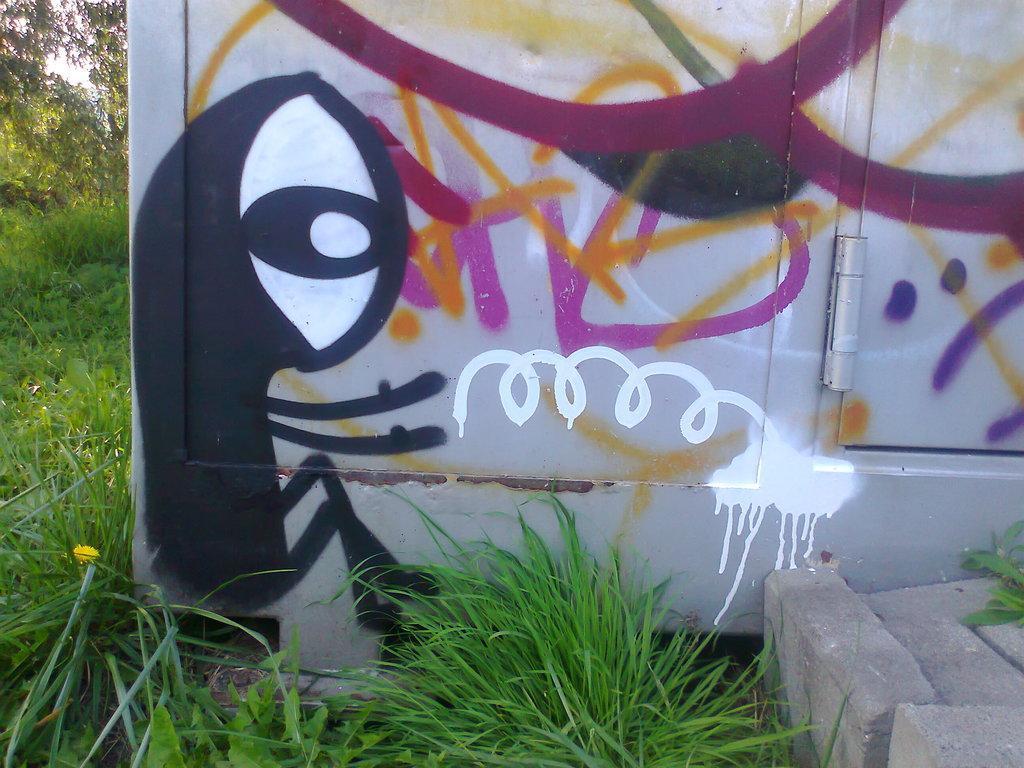Can you describe this image briefly? This picture is clicked outside. In the foreground we can see the green grass and a white color object on which we can see the pictures of some objects. On the right corner we can see a cement object. In the background we can see the trees and plants and some other objects. 